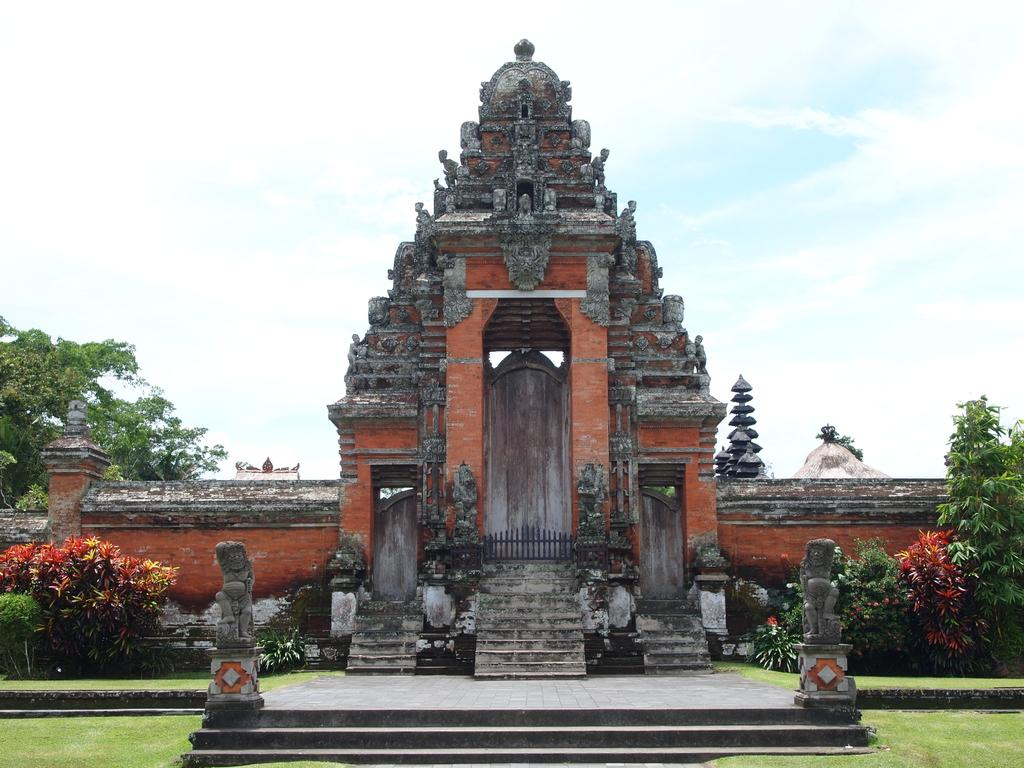What type of structure is visible in the image? There is an entrance to a temple in the image. What type of vegetation can be seen in the image? There are plants and trees visible in the image. What architectural feature is present in the image? There is a wall and steps visible in the image. What type of ground cover is present at the bottom of the image? Grass is present at the bottom of the image. What can be seen in the background of the image? There are trees and clouds in the sky in the background of the image. Where is the art displayed in the image? There is no art displayed in the image; it features an entrance to a temple, plants, trees, clouds, grass, walls, and steps. What type of seat can be seen in the image? There is no seat present in the image. 